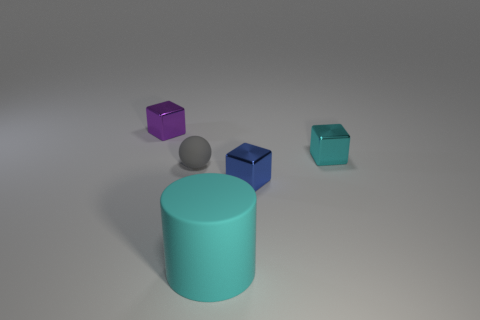How many gray things are either big cylinders or balls?
Make the answer very short. 1. Are there more cyan metal things that are in front of the small matte sphere than small cyan rubber balls?
Offer a terse response. No. Does the rubber cylinder have the same size as the ball?
Keep it short and to the point. No. There is a object that is made of the same material as the gray sphere; what is its color?
Provide a short and direct response. Cyan. Is the number of tiny purple things that are on the left side of the big cyan cylinder the same as the number of cyan shiny things that are to the left of the blue thing?
Ensure brevity in your answer.  No. What shape is the cyan object on the left side of the small shiny thing in front of the sphere?
Ensure brevity in your answer.  Cylinder. There is a purple thing that is the same shape as the small cyan thing; what is its material?
Your answer should be very brief. Metal. There is a rubber thing that is the same size as the blue shiny object; what is its color?
Your answer should be compact. Gray. Are there an equal number of small gray balls in front of the large matte cylinder and cyan things?
Keep it short and to the point. No. There is a metallic thing that is behind the cyan thing that is to the right of the cyan rubber thing; what color is it?
Your answer should be compact. Purple. 